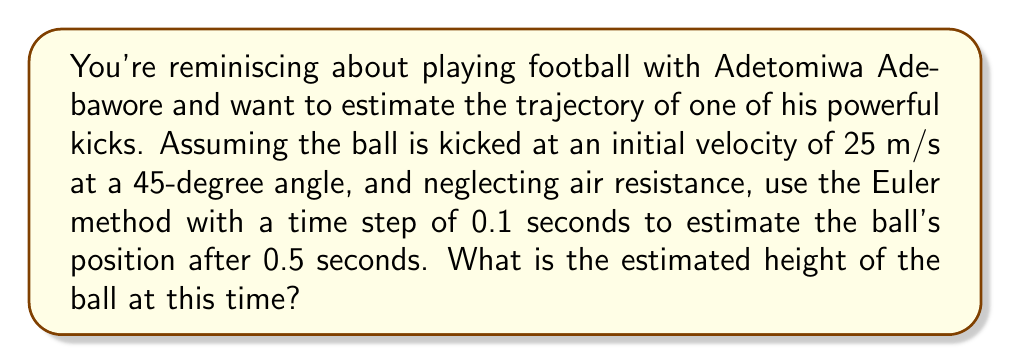Provide a solution to this math problem. Let's approach this step-by-step using the Euler method:

1) First, we need to set up our initial conditions:
   - Initial velocity: $v_0 = 25$ m/s
   - Angle: $\theta = 45°$
   - Initial position: $(x_0, y_0) = (0, 0)$
   - Acceleration due to gravity: $g = 9.8$ m/s²
   - Time step: $\Delta t = 0.1$ s
   - Total time: $t = 0.5$ s

2) We can break down the initial velocity into x and y components:
   $v_{0x} = v_0 \cos(\theta) = 25 \cos(45°) \approx 17.68$ m/s
   $v_{0y} = v_0 \sin(\theta) = 25 \sin(45°) \approx 17.68$ m/s

3) The Euler method uses the following formulas:
   $x_{n+1} = x_n + v_x \Delta t$
   $y_{n+1} = y_n + v_y \Delta t$
   $v_{y,n+1} = v_{y,n} - g \Delta t$

4) Let's calculate for each time step:

   At t = 0.1 s:
   $x_1 = 0 + 17.68 * 0.1 = 1.768$ m
   $y_1 = 0 + 17.68 * 0.1 = 1.768$ m
   $v_{y,1} = 17.68 - 9.8 * 0.1 = 16.70$ m/s

   At t = 0.2 s:
   $x_2 = 1.768 + 17.68 * 0.1 = 3.536$ m
   $y_2 = 1.768 + 16.70 * 0.1 = 3.438$ m
   $v_{y,2} = 16.70 - 9.8 * 0.1 = 15.72$ m/s

   At t = 0.3 s:
   $x_3 = 3.536 + 17.68 * 0.1 = 5.304$ m
   $y_3 = 3.438 + 15.72 * 0.1 = 5.010$ m
   $v_{y,3} = 15.72 - 9.8 * 0.1 = 14.74$ m/s

   At t = 0.4 s:
   $x_4 = 5.304 + 17.68 * 0.1 = 7.072$ m
   $y_4 = 5.010 + 14.74 * 0.1 = 6.484$ m
   $v_{y,4} = 14.74 - 9.8 * 0.1 = 13.76$ m/s

   At t = 0.5 s:
   $x_5 = 7.072 + 17.68 * 0.1 = 8.840$ m
   $y_5 = 6.484 + 13.76 * 0.1 = 7.860$ m

5) Therefore, after 0.5 seconds, the estimated height of the ball is 7.860 meters.
Answer: 7.860 m 